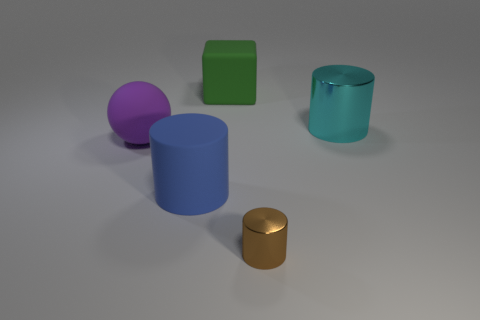Subtract all large cyan cylinders. How many cylinders are left? 2 Add 4 tiny purple metal blocks. How many objects exist? 9 Subtract 2 cylinders. How many cylinders are left? 1 Add 4 large blue cylinders. How many large blue cylinders are left? 5 Add 3 cylinders. How many cylinders exist? 6 Subtract all cyan cylinders. How many cylinders are left? 2 Subtract 0 gray blocks. How many objects are left? 5 Subtract all balls. How many objects are left? 4 Subtract all green balls. Subtract all red cubes. How many balls are left? 1 Subtract all yellow cylinders. How many brown blocks are left? 0 